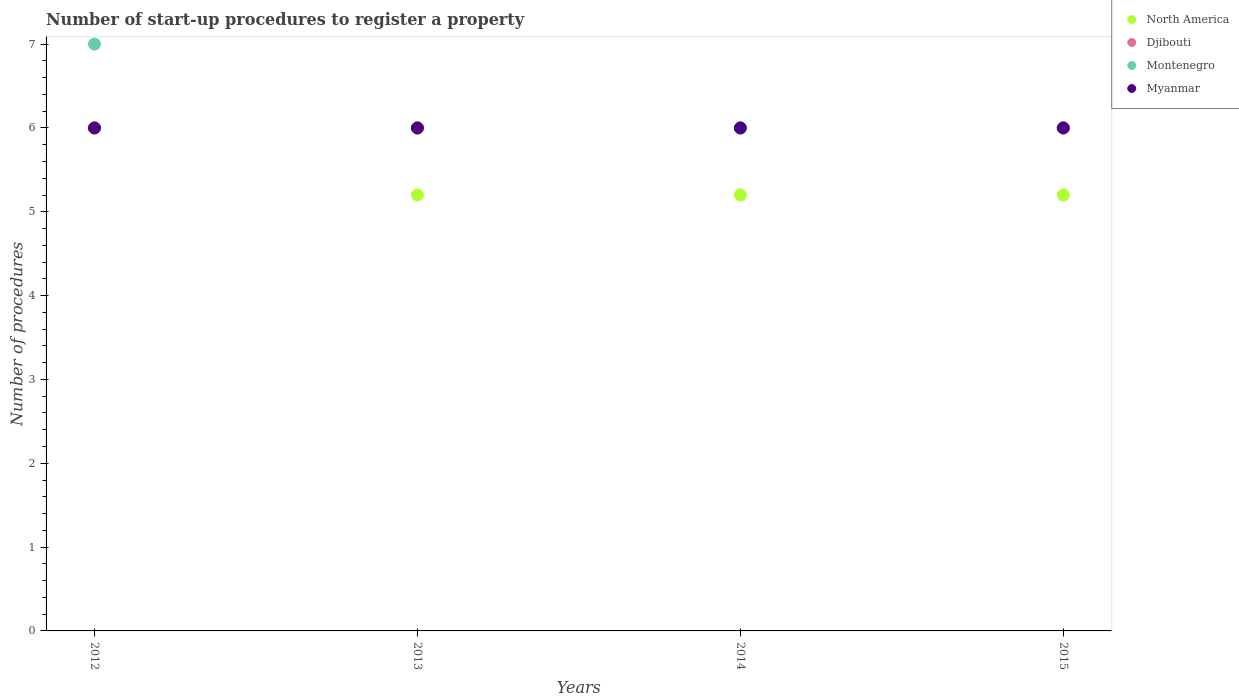How many different coloured dotlines are there?
Make the answer very short. 4. Is the number of dotlines equal to the number of legend labels?
Your answer should be very brief. Yes. Across all years, what is the minimum number of procedures required to register a property in North America?
Provide a succinct answer. 5.2. In which year was the number of procedures required to register a property in Montenegro minimum?
Your response must be concise. 2013. What is the total number of procedures required to register a property in Myanmar in the graph?
Offer a very short reply. 24. What is the difference between the number of procedures required to register a property in Myanmar in 2013 and the number of procedures required to register a property in Montenegro in 2014?
Your response must be concise. 0. In the year 2015, what is the difference between the number of procedures required to register a property in North America and number of procedures required to register a property in Myanmar?
Give a very brief answer. -0.8. What is the ratio of the number of procedures required to register a property in North America in 2013 to that in 2015?
Your response must be concise. 1. Is the number of procedures required to register a property in Montenegro in 2013 less than that in 2014?
Your response must be concise. No. Is the difference between the number of procedures required to register a property in North America in 2012 and 2014 greater than the difference between the number of procedures required to register a property in Myanmar in 2012 and 2014?
Offer a very short reply. Yes. What is the difference between the highest and the second highest number of procedures required to register a property in Djibouti?
Offer a very short reply. 0. What is the difference between the highest and the lowest number of procedures required to register a property in Djibouti?
Give a very brief answer. 0. In how many years, is the number of procedures required to register a property in Montenegro greater than the average number of procedures required to register a property in Montenegro taken over all years?
Give a very brief answer. 1. Is the sum of the number of procedures required to register a property in North America in 2014 and 2015 greater than the maximum number of procedures required to register a property in Myanmar across all years?
Ensure brevity in your answer.  Yes. Is the number of procedures required to register a property in Montenegro strictly greater than the number of procedures required to register a property in North America over the years?
Your response must be concise. Yes. How many years are there in the graph?
Give a very brief answer. 4. Does the graph contain grids?
Offer a terse response. No. Where does the legend appear in the graph?
Provide a succinct answer. Top right. What is the title of the graph?
Keep it short and to the point. Number of start-up procedures to register a property. What is the label or title of the Y-axis?
Your answer should be very brief. Number of procedures. What is the Number of procedures in Djibouti in 2012?
Your answer should be very brief. 6. What is the Number of procedures of Montenegro in 2012?
Your answer should be compact. 7. What is the Number of procedures of Myanmar in 2012?
Offer a terse response. 6. What is the Number of procedures in Djibouti in 2013?
Provide a succinct answer. 6. What is the Number of procedures in Montenegro in 2013?
Offer a very short reply. 6. What is the Number of procedures in Myanmar in 2013?
Your answer should be very brief. 6. What is the Number of procedures of North America in 2014?
Offer a very short reply. 5.2. What is the Number of procedures in Djibouti in 2014?
Your response must be concise. 6. What is the Number of procedures in Montenegro in 2014?
Your response must be concise. 6. What is the Number of procedures in North America in 2015?
Your answer should be very brief. 5.2. What is the Number of procedures in Djibouti in 2015?
Your answer should be very brief. 6. Across all years, what is the maximum Number of procedures of Myanmar?
Provide a succinct answer. 6. Across all years, what is the minimum Number of procedures of North America?
Keep it short and to the point. 5.2. Across all years, what is the minimum Number of procedures of Myanmar?
Your answer should be very brief. 6. What is the total Number of procedures in North America in the graph?
Offer a very short reply. 21.6. What is the total Number of procedures in Djibouti in the graph?
Provide a short and direct response. 24. What is the difference between the Number of procedures in Djibouti in 2012 and that in 2013?
Provide a short and direct response. 0. What is the difference between the Number of procedures in Montenegro in 2012 and that in 2014?
Provide a short and direct response. 1. What is the difference between the Number of procedures in North America in 2012 and that in 2015?
Keep it short and to the point. 0.8. What is the difference between the Number of procedures of Djibouti in 2012 and that in 2015?
Ensure brevity in your answer.  0. What is the difference between the Number of procedures of Myanmar in 2012 and that in 2015?
Offer a very short reply. 0. What is the difference between the Number of procedures in North America in 2013 and that in 2014?
Keep it short and to the point. 0. What is the difference between the Number of procedures of Montenegro in 2013 and that in 2014?
Your answer should be very brief. 0. What is the difference between the Number of procedures in North America in 2013 and that in 2015?
Offer a very short reply. 0. What is the difference between the Number of procedures of Djibouti in 2013 and that in 2015?
Your answer should be very brief. 0. What is the difference between the Number of procedures in Myanmar in 2013 and that in 2015?
Your response must be concise. 0. What is the difference between the Number of procedures in Djibouti in 2014 and that in 2015?
Your answer should be very brief. 0. What is the difference between the Number of procedures in Montenegro in 2014 and that in 2015?
Keep it short and to the point. 0. What is the difference between the Number of procedures of North America in 2012 and the Number of procedures of Djibouti in 2013?
Your response must be concise. 0. What is the difference between the Number of procedures in North America in 2012 and the Number of procedures in Myanmar in 2013?
Ensure brevity in your answer.  0. What is the difference between the Number of procedures in Djibouti in 2012 and the Number of procedures in Montenegro in 2013?
Provide a short and direct response. 0. What is the difference between the Number of procedures in Djibouti in 2012 and the Number of procedures in Myanmar in 2013?
Offer a terse response. 0. What is the difference between the Number of procedures in Montenegro in 2012 and the Number of procedures in Myanmar in 2013?
Provide a short and direct response. 1. What is the difference between the Number of procedures of North America in 2012 and the Number of procedures of Montenegro in 2014?
Keep it short and to the point. 0. What is the difference between the Number of procedures in North America in 2012 and the Number of procedures in Myanmar in 2014?
Keep it short and to the point. 0. What is the difference between the Number of procedures in Djibouti in 2012 and the Number of procedures in Montenegro in 2014?
Offer a terse response. 0. What is the difference between the Number of procedures in Djibouti in 2012 and the Number of procedures in Myanmar in 2014?
Your answer should be compact. 0. What is the difference between the Number of procedures of Montenegro in 2012 and the Number of procedures of Myanmar in 2014?
Your answer should be very brief. 1. What is the difference between the Number of procedures in North America in 2012 and the Number of procedures in Djibouti in 2015?
Ensure brevity in your answer.  0. What is the difference between the Number of procedures of North America in 2012 and the Number of procedures of Myanmar in 2015?
Provide a succinct answer. 0. What is the difference between the Number of procedures of Djibouti in 2012 and the Number of procedures of Montenegro in 2015?
Your answer should be very brief. 0. What is the difference between the Number of procedures in Djibouti in 2012 and the Number of procedures in Myanmar in 2015?
Provide a short and direct response. 0. What is the difference between the Number of procedures of Montenegro in 2012 and the Number of procedures of Myanmar in 2015?
Make the answer very short. 1. What is the difference between the Number of procedures of Djibouti in 2013 and the Number of procedures of Montenegro in 2014?
Provide a short and direct response. 0. What is the difference between the Number of procedures of North America in 2013 and the Number of procedures of Montenegro in 2015?
Provide a short and direct response. -0.8. What is the difference between the Number of procedures in Djibouti in 2013 and the Number of procedures in Myanmar in 2015?
Offer a terse response. 0. What is the difference between the Number of procedures of North America in 2014 and the Number of procedures of Djibouti in 2015?
Keep it short and to the point. -0.8. What is the difference between the Number of procedures of North America in 2014 and the Number of procedures of Montenegro in 2015?
Keep it short and to the point. -0.8. What is the difference between the Number of procedures in Djibouti in 2014 and the Number of procedures in Montenegro in 2015?
Your response must be concise. 0. What is the average Number of procedures of North America per year?
Your response must be concise. 5.4. What is the average Number of procedures of Djibouti per year?
Your answer should be very brief. 6. What is the average Number of procedures in Montenegro per year?
Make the answer very short. 6.25. What is the average Number of procedures in Myanmar per year?
Your answer should be very brief. 6. In the year 2012, what is the difference between the Number of procedures in North America and Number of procedures in Djibouti?
Ensure brevity in your answer.  0. In the year 2012, what is the difference between the Number of procedures of Djibouti and Number of procedures of Montenegro?
Your answer should be very brief. -1. In the year 2012, what is the difference between the Number of procedures in Djibouti and Number of procedures in Myanmar?
Keep it short and to the point. 0. In the year 2013, what is the difference between the Number of procedures in North America and Number of procedures in Montenegro?
Offer a very short reply. -0.8. In the year 2013, what is the difference between the Number of procedures of North America and Number of procedures of Myanmar?
Your answer should be compact. -0.8. In the year 2013, what is the difference between the Number of procedures in Djibouti and Number of procedures in Myanmar?
Offer a terse response. 0. In the year 2013, what is the difference between the Number of procedures of Montenegro and Number of procedures of Myanmar?
Offer a very short reply. 0. In the year 2014, what is the difference between the Number of procedures of North America and Number of procedures of Montenegro?
Your answer should be compact. -0.8. In the year 2014, what is the difference between the Number of procedures of North America and Number of procedures of Myanmar?
Your answer should be very brief. -0.8. In the year 2015, what is the difference between the Number of procedures in North America and Number of procedures in Montenegro?
Ensure brevity in your answer.  -0.8. In the year 2015, what is the difference between the Number of procedures of North America and Number of procedures of Myanmar?
Make the answer very short. -0.8. In the year 2015, what is the difference between the Number of procedures in Djibouti and Number of procedures in Myanmar?
Give a very brief answer. 0. What is the ratio of the Number of procedures of North America in 2012 to that in 2013?
Your answer should be very brief. 1.15. What is the ratio of the Number of procedures of Montenegro in 2012 to that in 2013?
Give a very brief answer. 1.17. What is the ratio of the Number of procedures of North America in 2012 to that in 2014?
Provide a short and direct response. 1.15. What is the ratio of the Number of procedures of Djibouti in 2012 to that in 2014?
Provide a succinct answer. 1. What is the ratio of the Number of procedures of Myanmar in 2012 to that in 2014?
Ensure brevity in your answer.  1. What is the ratio of the Number of procedures of North America in 2012 to that in 2015?
Provide a short and direct response. 1.15. What is the ratio of the Number of procedures of Myanmar in 2012 to that in 2015?
Your response must be concise. 1. What is the ratio of the Number of procedures of North America in 2013 to that in 2014?
Keep it short and to the point. 1. What is the ratio of the Number of procedures in Myanmar in 2013 to that in 2014?
Your answer should be very brief. 1. What is the difference between the highest and the second highest Number of procedures in North America?
Give a very brief answer. 0.8. What is the difference between the highest and the second highest Number of procedures of Djibouti?
Keep it short and to the point. 0. What is the difference between the highest and the lowest Number of procedures of Djibouti?
Your answer should be very brief. 0. 